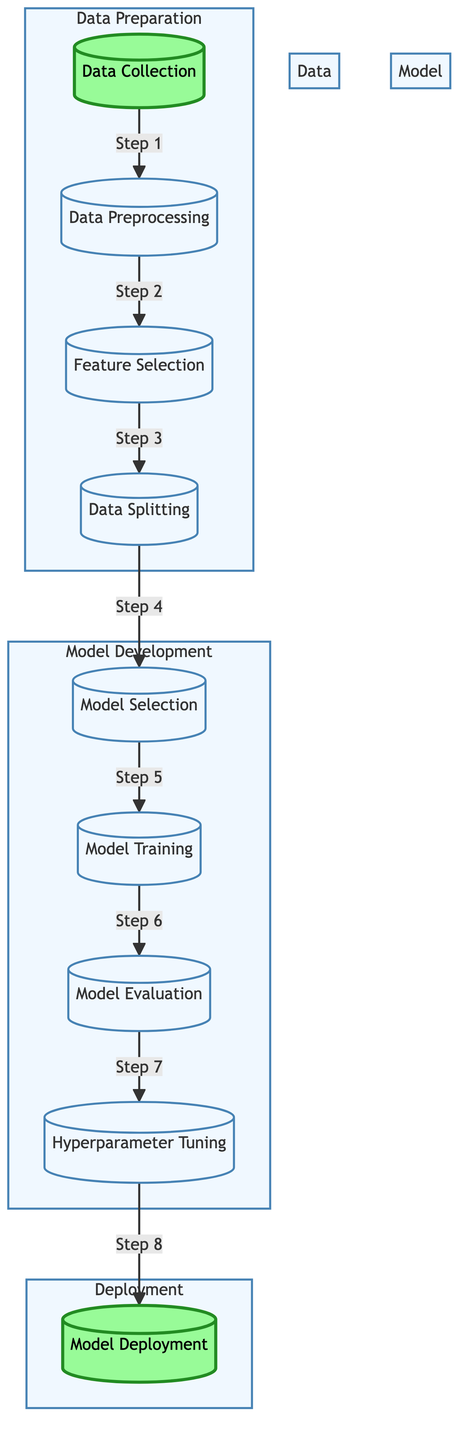What is the first step in the diagram? The diagram indicates that the first step is "Data Collection" as this is the first node connected to the rest of the process.
Answer: Data Collection How many main steps are there in total? There are nine main steps listed in the diagram, which can be counted from the nodes presented.
Answer: Nine Which two steps are included in the Data Preparation subgraph? The Data Preparation subgraph includes "Data Collection" and "Data Preprocessing," which are clearly shown within the subgraph boundaries.
Answer: Data Collection and Data Preprocessing What is the last step before model deployment? The last step before model deployment is "Hyperparameter Tuning," as it directly precedes the "Model Deployment" node in the flow.
Answer: Hyperparameter Tuning How many steps are in the Model Development subgraph? There are four steps in the Model Development subgraph: "Model Selection," "Model Training," "Model Evaluation," and "Hyperparameter Tuning," which can be identified within that section of the diagram.
Answer: Four What type of diagram is displayed? The displayed diagram is a "Machine Learning Diagram," which organizes the machine learning process into structured steps.
Answer: Machine Learning Diagram Which step follows after "Model Evaluation"? "Hyperparameter Tuning" follows after "Model Evaluation," as indicated by the arrow leading from the evaluation step to the tuning step in the flow.
Answer: Hyperparameter Tuning What color represents the Deployment subgraph? The Deployment subgraph is represented by the color light green, as shown in the diagram's style for that specific section.
Answer: Light green 